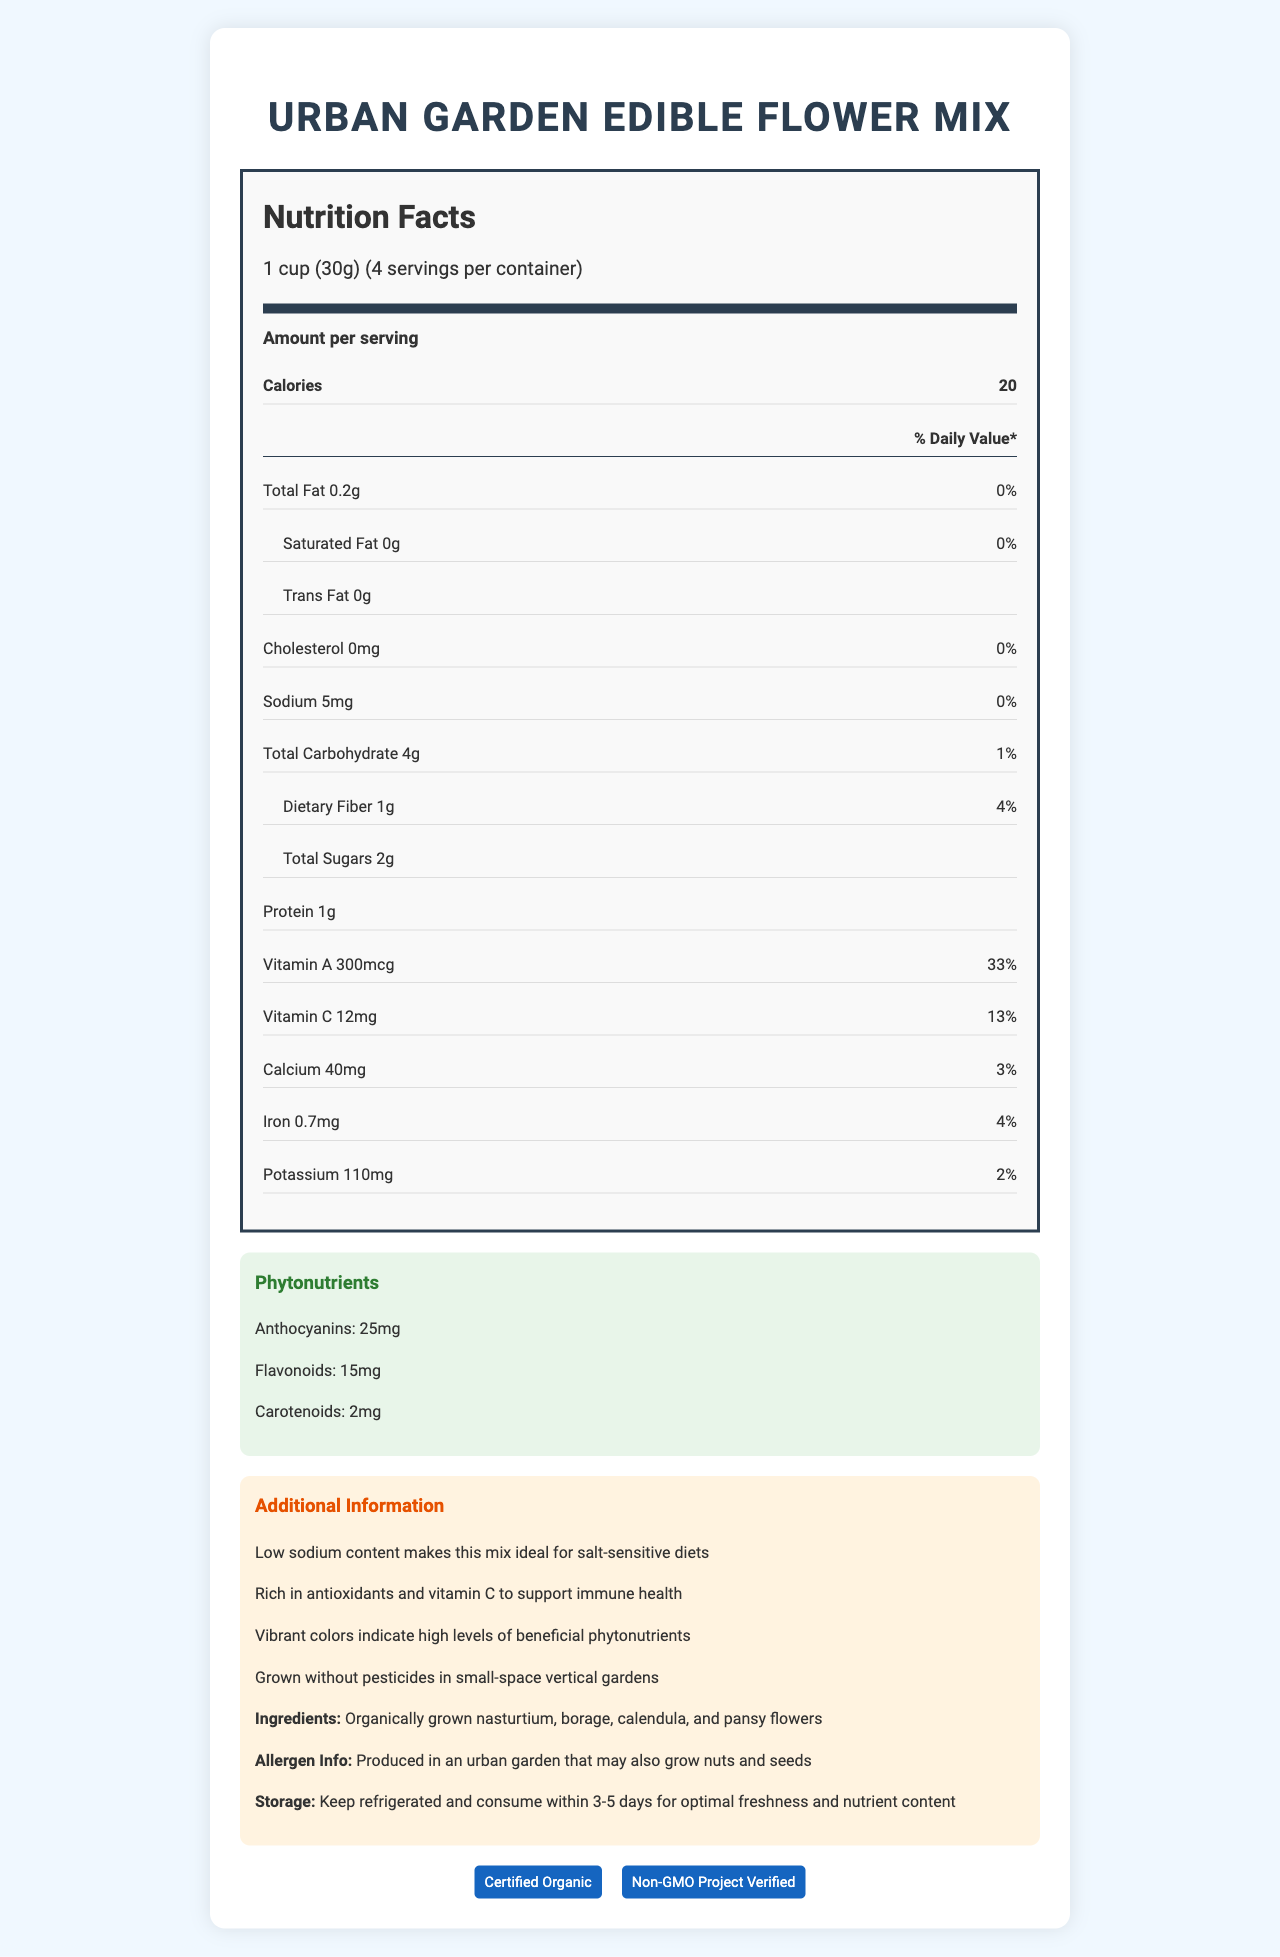what is the serving size? The document states that the serving size is 1 cup (30g).
Answer: 1 cup (30g) how many servings are in the container? The servings per container are listed as 4 in the nutrition facts.
Answer: 4 how many calories are in one serving? The calories per serving are noted as 20.
Answer: 20 how much sodium is in one serving? The sodium content per serving is listed as 5mg.
Answer: 5mg what is the percentage daily value of vitamin A in one serving? The percentage daily value for vitamin A is 33%, as shown in the nutrition facts.
Answer: 33% how much protein does one serving contain? A. 2g B. 5g C. 1g D. None The document indicates that each serving contains 1g of protein.
Answer: C. 1g what is the total carbohydrate content per serving? A. 2g B. 3g C. 5g D. 4g Total carbohydrate content per serving is 4g as specified in the nutrition facts.
Answer: D. 4g are these edible flowers high in sodium? The sodium content is very low, only 5mg per serving, which is reflected by the 0% daily value.
Answer: No do these servings contain any trans fat? The nutrition facts label shows that there is 0g of trans fat per serving.
Answer: No what phytonutrients are included in the urban garden edible flower mix? The phytonutrients listed are Anthocyanins (25mg), Flavonoids (15mg), and Carotenoids (2mg).
Answer: Anthocyanins, Flavonoids, Carotenoids what is the cholesterol content per serving? The document states the cholesterol content per serving is 0mg.
Answer: 0mg which statement is true about the edible flower mix? A. It is high in sodium B. It is grown without pesticides C. It contains artificial colors The document indicates that the flowers are grown without pesticides in small-space vertical gardens.
Answer: B. It is grown without pesticides what are the certifications associated with the urban garden edible flower mix? The certifications listed are Certified Organic and Non-GMO Project Verified.
Answer: Certified Organic and Non-GMO Project Verified what should be done to maintain optimal freshness and nutrient content of these edible flowers? The storage instructions mention that the flowers should be kept refrigerated and consumed within 3-5 days.
Answer: Keep refrigerated and consume within 3-5 days describe the main idea of the document The document outlines detailed nutritional data, underscores beneficial qualities like low sodium, lists ingredients, includes allergen information and storage instructions, and mentions organic and non-GMO certifications.
Answer: The document provides the nutrition facts, unique phytonutrients, and additional information for the Urban Garden Edible Flower Mix. It highlights the low sodium content, ingredients, allergen info, storage instructions, and certifications such as Certified Organic and Non-GMO Project Verified. can you tell if the flowers are safe for people with nut allergies from this document alone? The document states that the flowers are produced in an urban garden that may also grow nuts and seeds, so the information provided is not enough to ensure safety for individuals with nut allergies.
Answer: No 